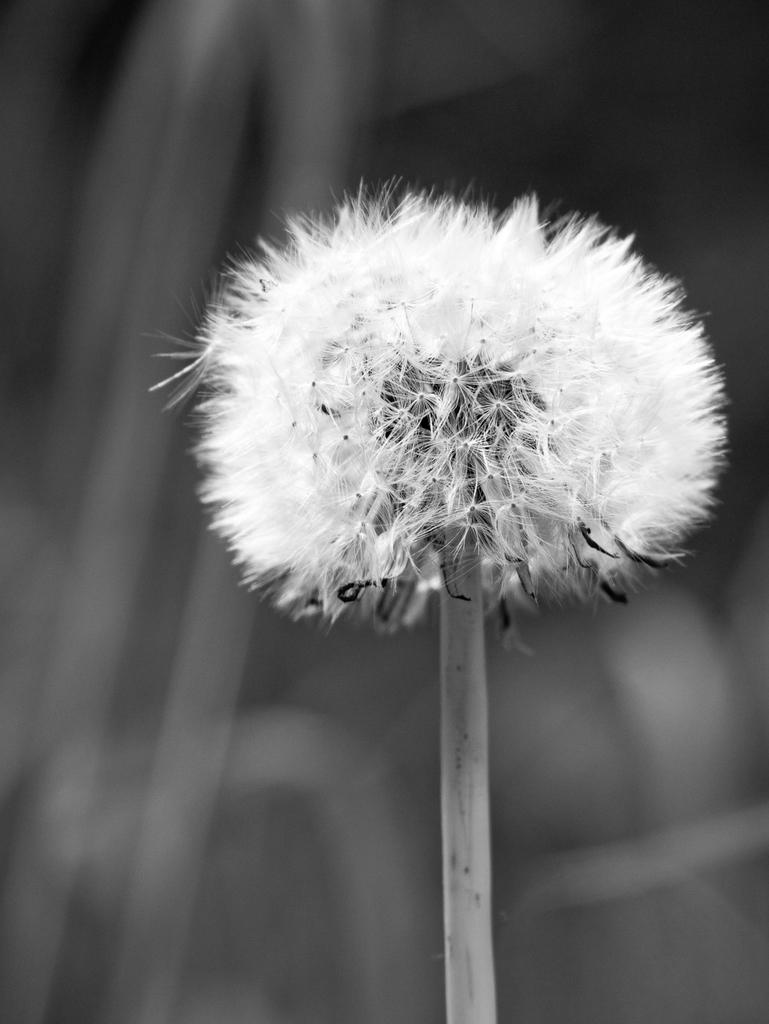What is the main subject of the picture? The main subject of the picture is a stem with a flower. Can you describe the background of the image? The background of the image is blurry. How many icicles are hanging from the flower in the image? There are no icicles present in the image; it features a stem with a flower. What type of tomatoes can be seen growing on the sidewalk in the image? There is no sidewalk or tomatoes present in the image. 